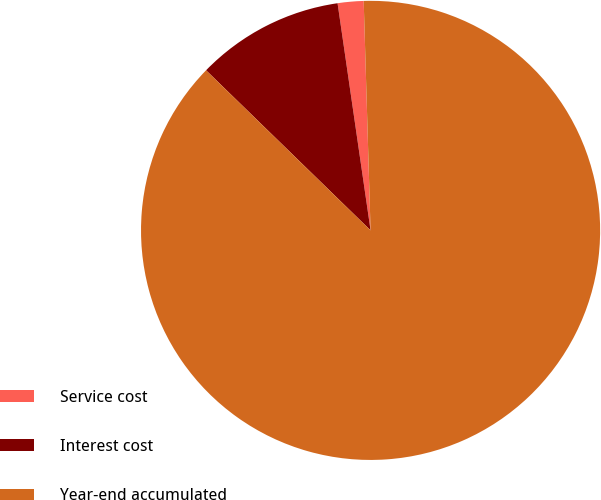Convert chart. <chart><loc_0><loc_0><loc_500><loc_500><pie_chart><fcel>Service cost<fcel>Interest cost<fcel>Year-end accumulated<nl><fcel>1.82%<fcel>10.42%<fcel>87.76%<nl></chart> 